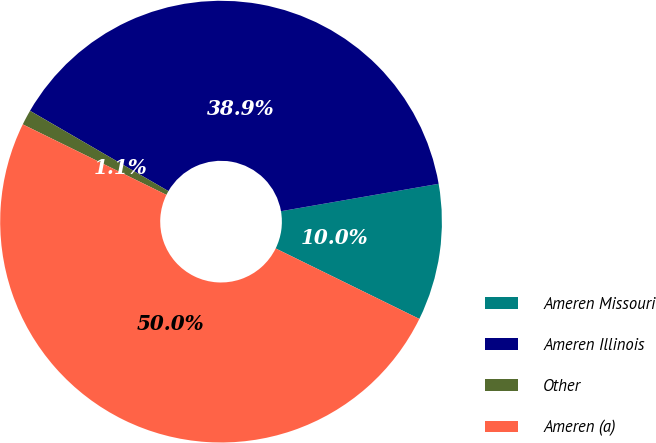Convert chart. <chart><loc_0><loc_0><loc_500><loc_500><pie_chart><fcel>Ameren Missouri<fcel>Ameren Illinois<fcel>Other<fcel>Ameren (a)<nl><fcel>10.0%<fcel>38.89%<fcel>1.11%<fcel>50.0%<nl></chart> 